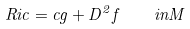<formula> <loc_0><loc_0><loc_500><loc_500>R i c = c g + D ^ { 2 } f \quad i n M</formula> 